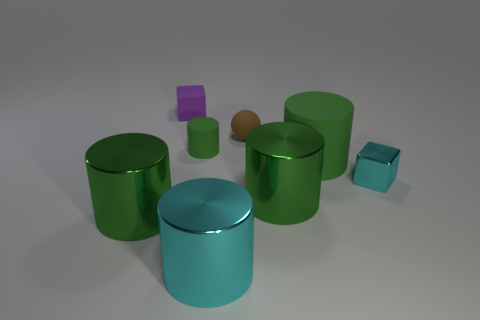Is there anything else that is the same shape as the brown rubber thing?
Give a very brief answer. No. Is the shape of the cyan metallic object that is in front of the tiny metallic cube the same as the big green thing that is behind the tiny cyan shiny object?
Ensure brevity in your answer.  Yes. Are the large object to the left of the small cylinder and the tiny block that is behind the big green rubber cylinder made of the same material?
Keep it short and to the point. No. There is a green thing behind the big green cylinder behind the small cyan metal cube; what is its material?
Provide a succinct answer. Rubber. There is a brown matte object that is behind the big green thing that is left of the cyan shiny object on the left side of the tiny cyan metal thing; what is its shape?
Offer a terse response. Sphere. There is another small thing that is the same shape as the tiny cyan metallic thing; what material is it?
Your response must be concise. Rubber. How many brown objects are there?
Provide a succinct answer. 1. What shape is the tiny shiny object behind the cyan cylinder?
Make the answer very short. Cube. What is the color of the tiny block that is behind the tiny metal cube behind the green metal object that is on the right side of the tiny brown matte object?
Your answer should be compact. Purple. There is a purple thing that is the same material as the small brown thing; what is its shape?
Give a very brief answer. Cube. 